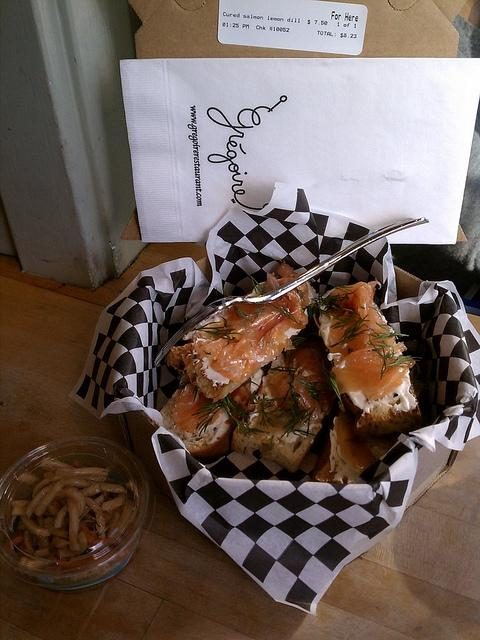The basket of salmon is currently being eaten at which location?

Choices:
A) restaurant
B) car
C) work
D) home restaurant 